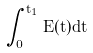<formula> <loc_0><loc_0><loc_500><loc_500>\int _ { 0 } ^ { t _ { 1 } } E ( t ) d t</formula> 